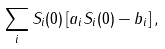<formula> <loc_0><loc_0><loc_500><loc_500>\sum _ { i } S _ { i } ( 0 ) \left [ a _ { i } S _ { i } ( 0 ) - b _ { i } \right ] ,</formula> 